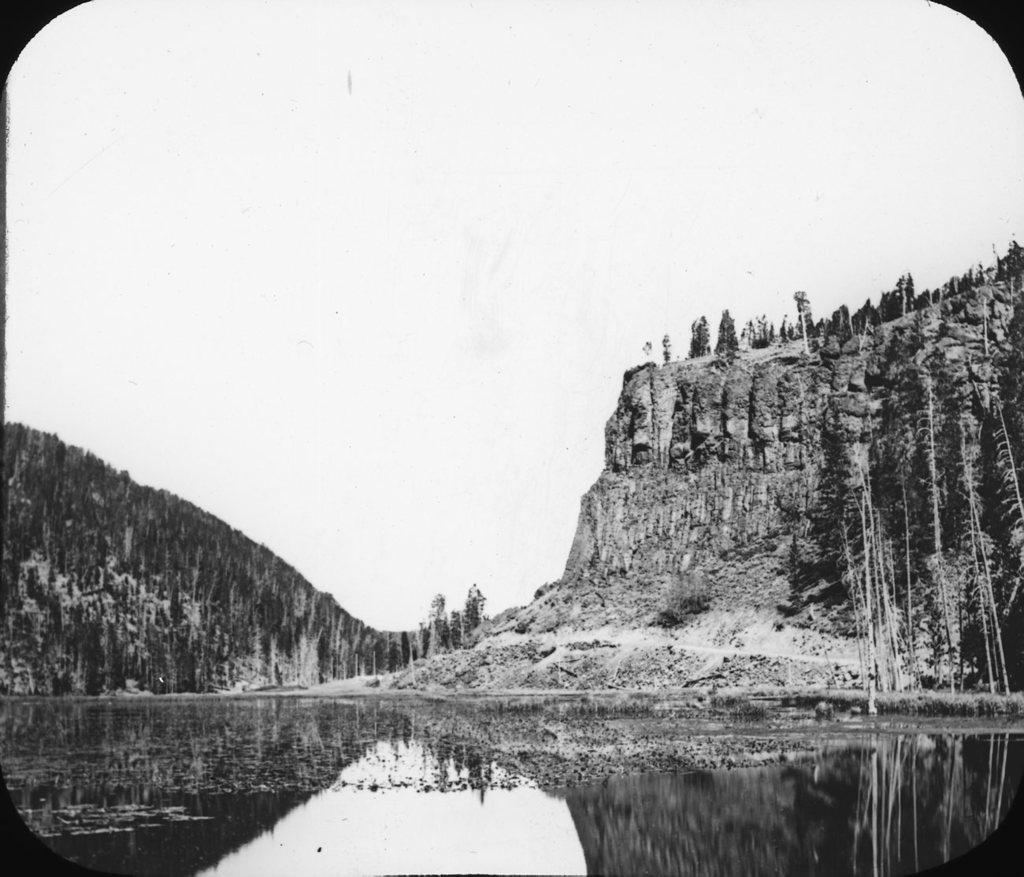What is the color scheme of the image? The image is black and white. What can be seen at the bottom of the image? There is water visible at the bottom of the image. What type of landscape feature is present in the background of the image? There are hills in the background of the image. What is visible at the top of the image? The sky is visible at the top of the image. Where is the monkey sitting in the image? There is no monkey present in the image. What type of pickle is being served by the maid in the image? There is no maid or pickle present in the image. 